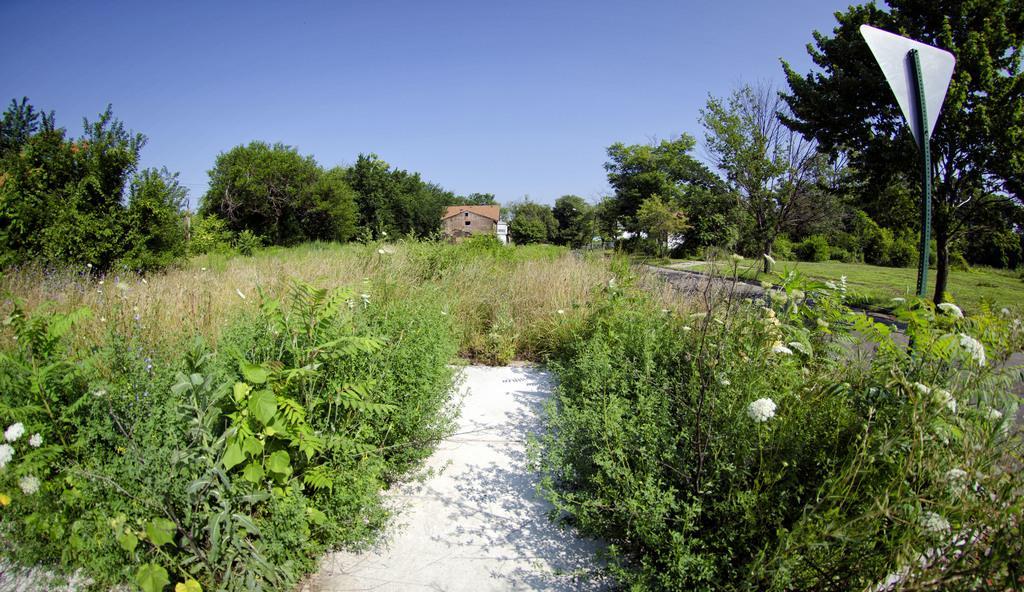How would you summarize this image in a sentence or two? In this picture I can see many trees, plants and grass. On the right there is a sign board. In the background I can see the shed and building. At the top i can see the sky. In the bottom right I can see some flowers on the plants. 